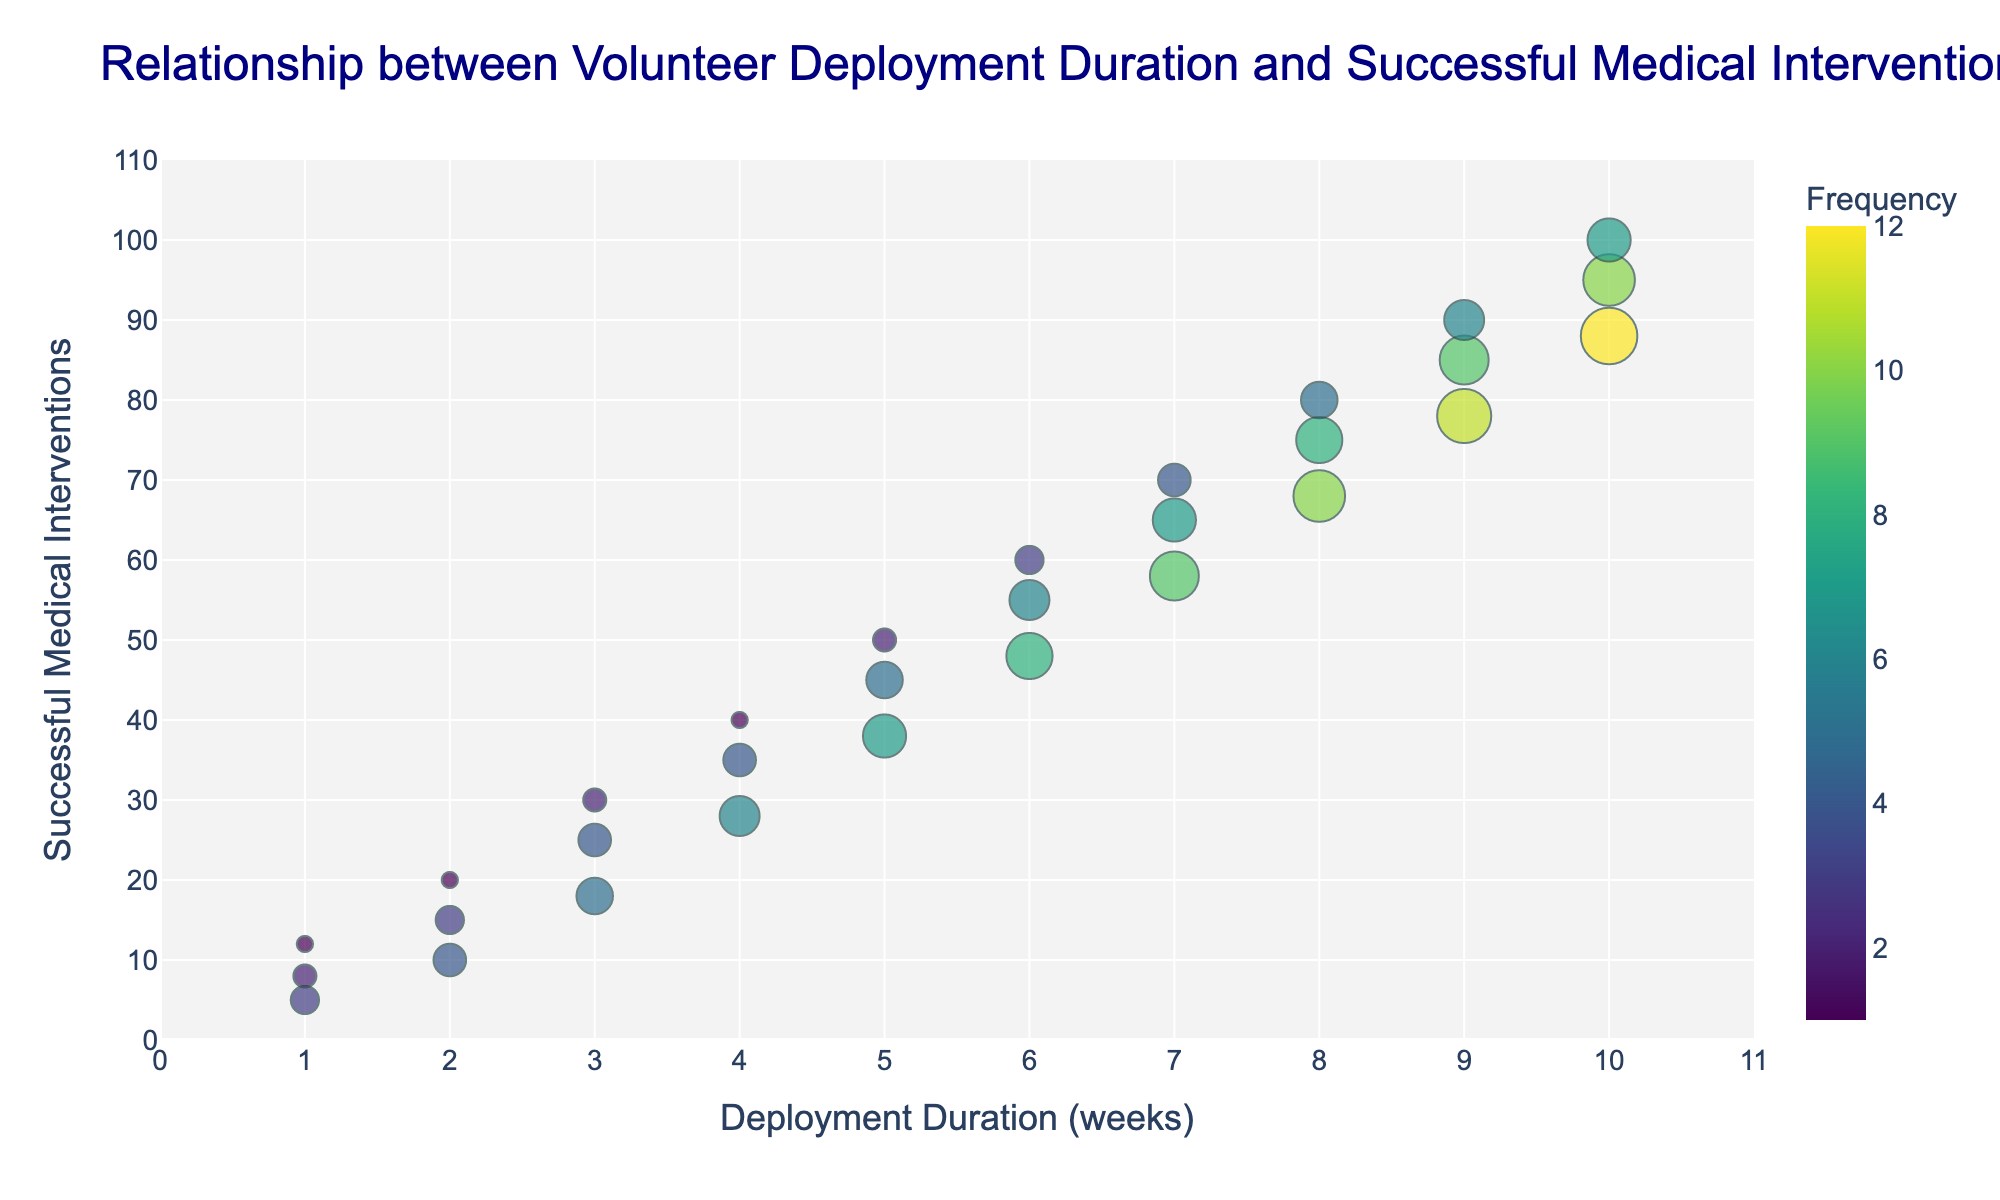What is the title of the plot? The title is usually placed at the top of the plot, and for titles, it's written in large font.
Answer: Relationship between Volunteer Deployment Duration and Successful Medical Interventions How many data points are displayed in the plot? Each bubble on the scatterplot represents a data point. Counting all these bubbles gives the total number of data points.
Answer: 30 What is the range of successful medical interventions shown on the plot? The y-axis shows the range of successful medical interventions, denoted by the minimum and maximum values on that axis.
Answer: 0-100 What is the color of the highest frequency bubbles? The colors of the bubbles range according to the color spectrum provided, with the highest frequencies shown in the brightest color on the color scale (usually a lighter color in a Viridis color scheme).
Answer: Bright Yellow Which deployment duration shows the highest number of successful interventions? Look for the highest value on the y-axis and observe its corresponding x-value. The bubble at deployment duration 10 weeks corresponds to 100 successful interventions.
Answer: 10 weeks What is the deployment duration with the highest frequency of successful interventions? Identify the bubble with the largest size, indicating the highest frequency, and check its x-axis value. The largest bubble appears at a deployment duration of 10 weeks, meaning volunteers deployed for this duration achieved the highest frequency of successful interventions.
Answer: 10 weeks What is the average frequency for deployments lasting 5 weeks? Locate all the bubbles along the 5-week deployment duration on the x-axis, sum their frequencies, and divide by the number of such bubbles. \( (7 + 5 + 2) / 3 = 14 / 3 = 4.67 \)
Answer: 4.67 Compare the number of successful medical interventions for deployment durations of 7 and 8 weeks. Which one is higher and by how much? Identify the y-values for bubbles corresponding to 7 and 8 weeks deployment durations and compare them. The highest intervention for 7 weeks is 70, while it's 80 for 8 weeks. The difference is \(80 - 70 = 10\).
Answer: 8 weeks by 10 interventions What deployment duration is associated with the most variations in successful medical interventions? Look for the deployment duration (x-axis value) with the widest range of y-axis values. Deployment duration of 9 weeks shows successful interventions ranging from 78 to 90, indicating the most variations.
Answer: 9 weeks Which duration shows an increasing trend in the number of medical interventions with increasing frequency? Identify the deployment duration (x-axis value) where bubbles, as frequency increases, form a clear upward trend in successful interventions (y-axis value). The deployment duration of 6 weeks shows this trend.
Answer: 6 weeks 